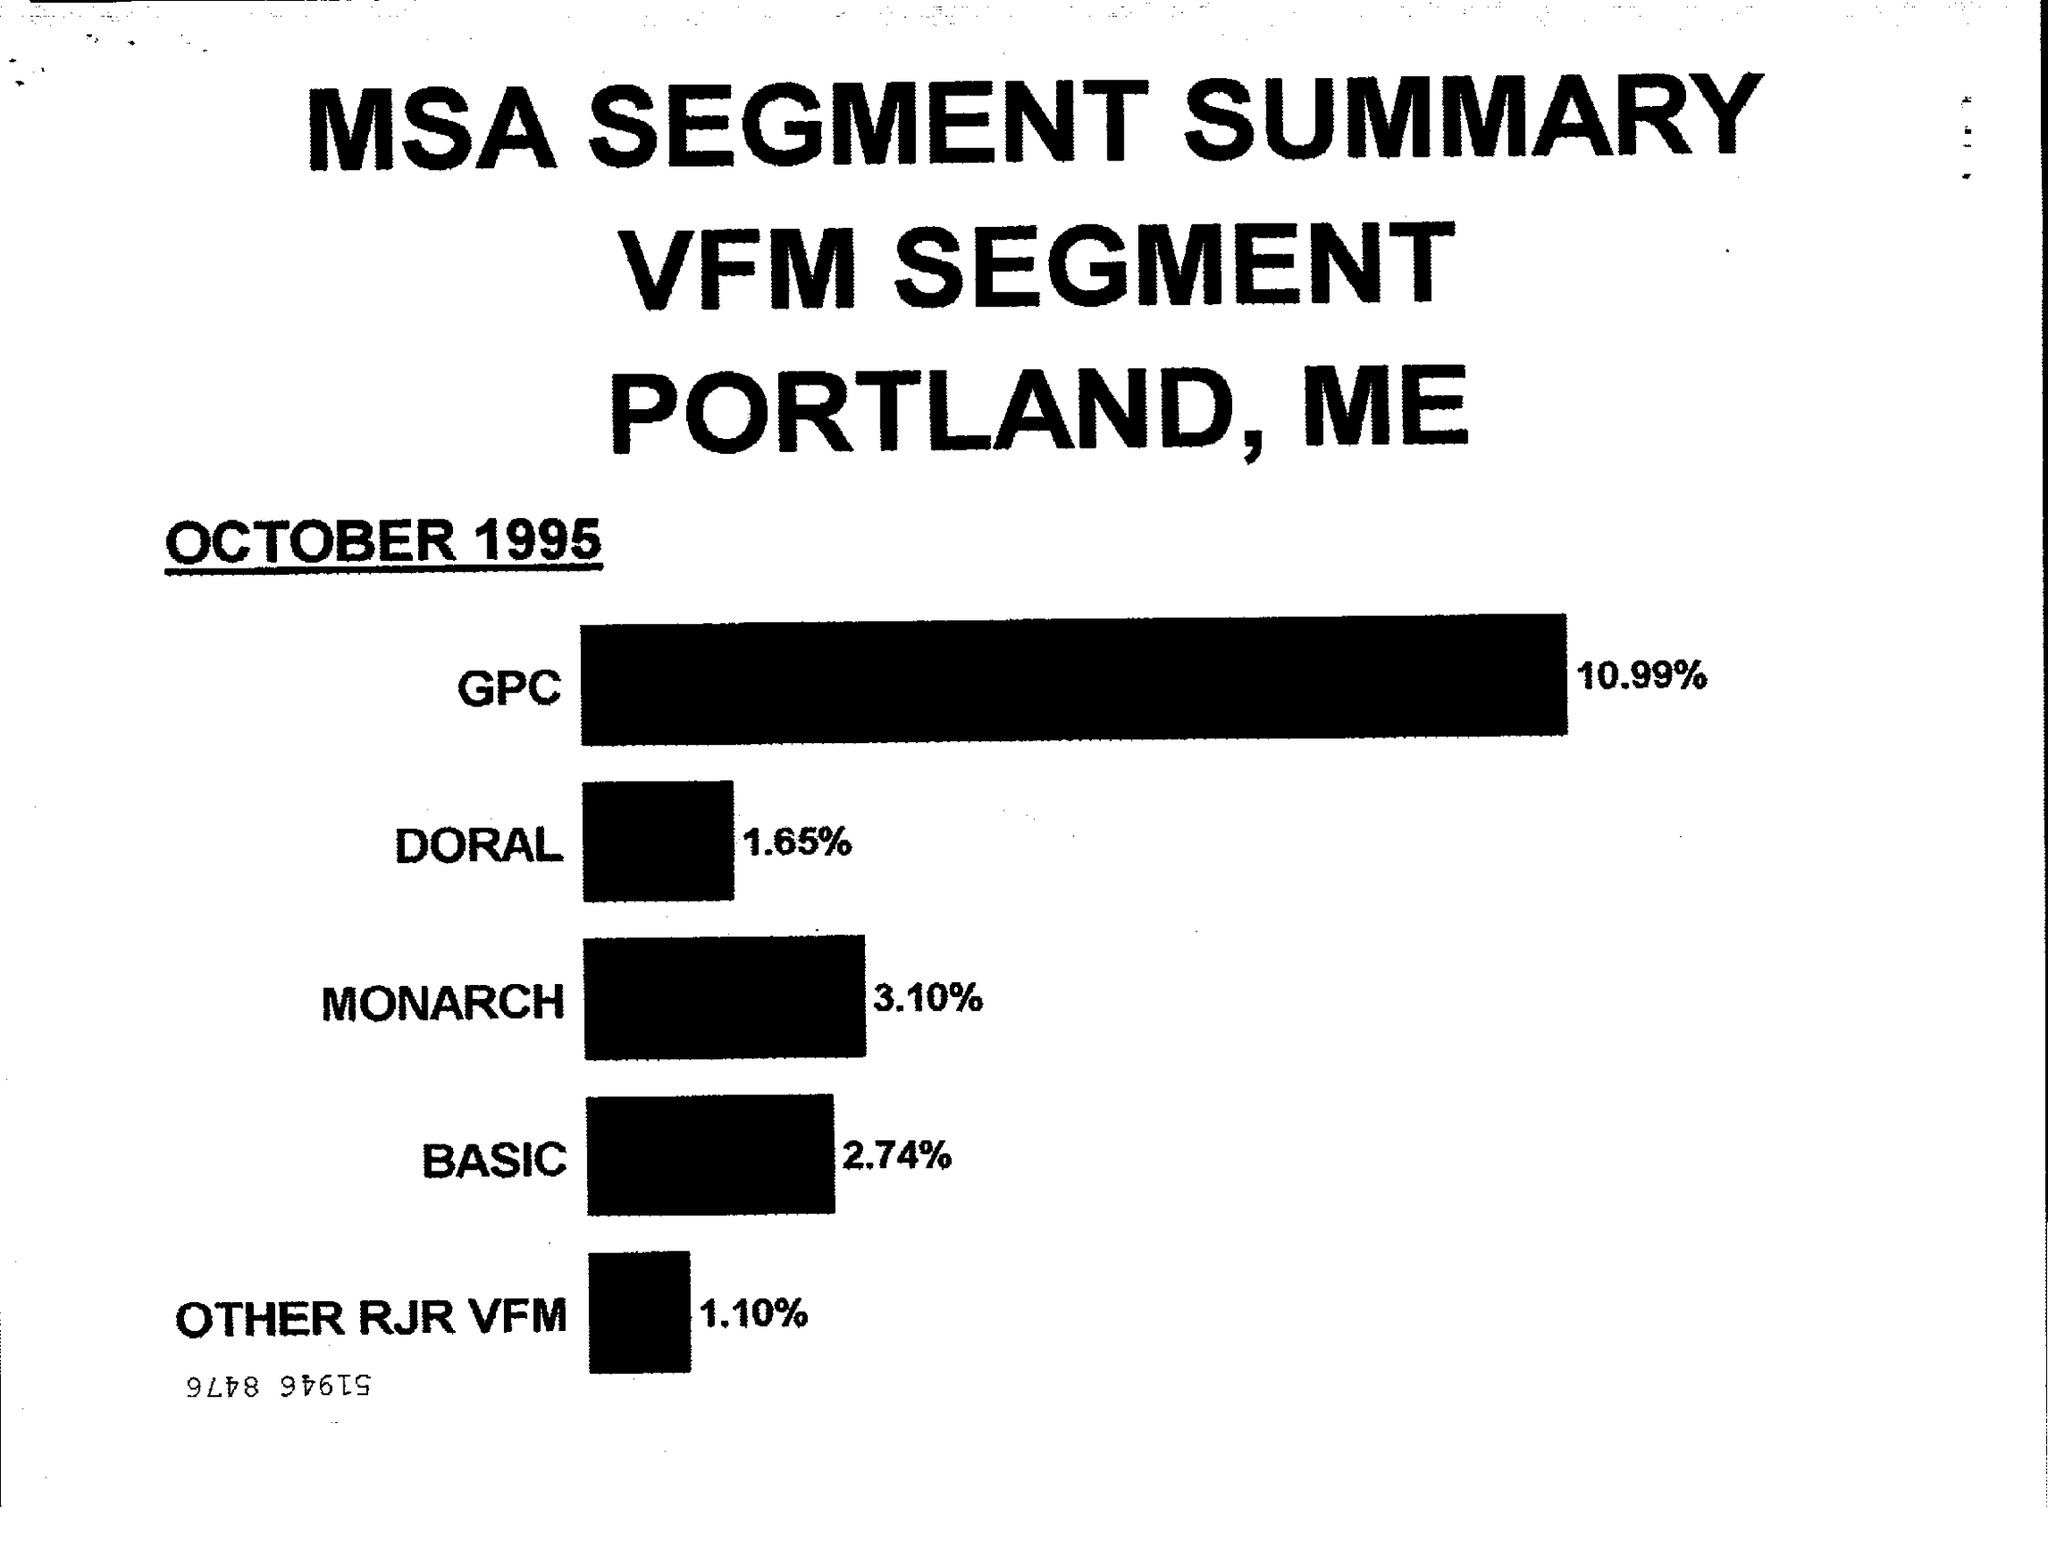When is the document dated?
Give a very brief answer. OCTOBER 1995. What is the percentage of GPC?
Make the answer very short. 10.99%. 